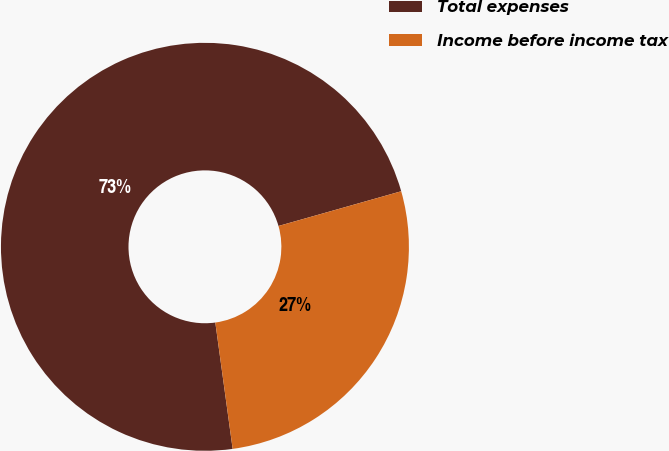<chart> <loc_0><loc_0><loc_500><loc_500><pie_chart><fcel>Total expenses<fcel>Income before income tax<nl><fcel>72.78%<fcel>27.22%<nl></chart> 